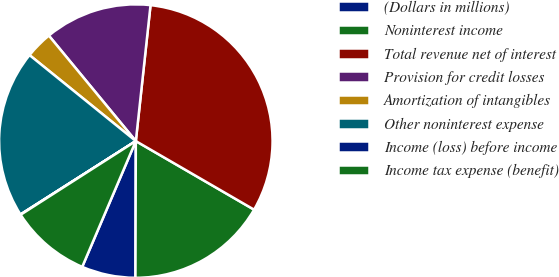Convert chart to OTSL. <chart><loc_0><loc_0><loc_500><loc_500><pie_chart><fcel>(Dollars in millions)<fcel>Noninterest income<fcel>Total revenue net of interest<fcel>Provision for credit losses<fcel>Amortization of intangibles<fcel>Other noninterest expense<fcel>Income (loss) before income<fcel>Income tax expense (benefit)<nl><fcel>6.37%<fcel>16.68%<fcel>31.65%<fcel>12.69%<fcel>3.2%<fcel>19.84%<fcel>0.04%<fcel>9.53%<nl></chart> 